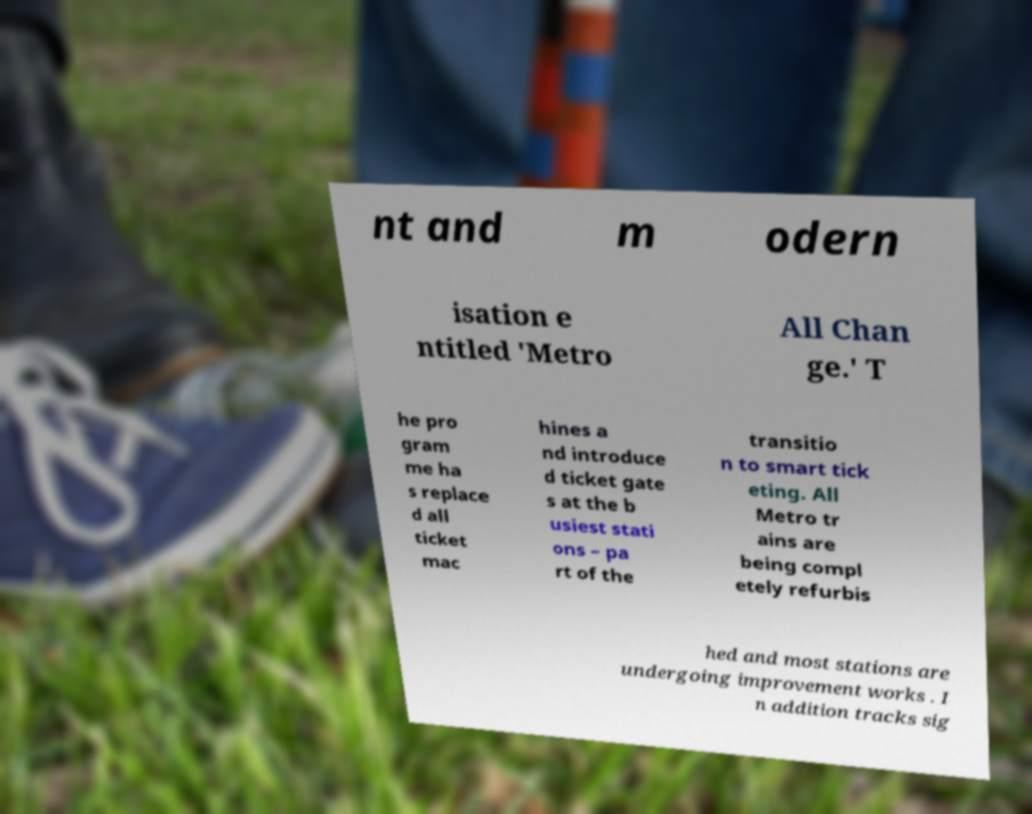There's text embedded in this image that I need extracted. Can you transcribe it verbatim? nt and m odern isation e ntitled 'Metro All Chan ge.' T he pro gram me ha s replace d all ticket mac hines a nd introduce d ticket gate s at the b usiest stati ons – pa rt of the transitio n to smart tick eting. All Metro tr ains are being compl etely refurbis hed and most stations are undergoing improvement works . I n addition tracks sig 